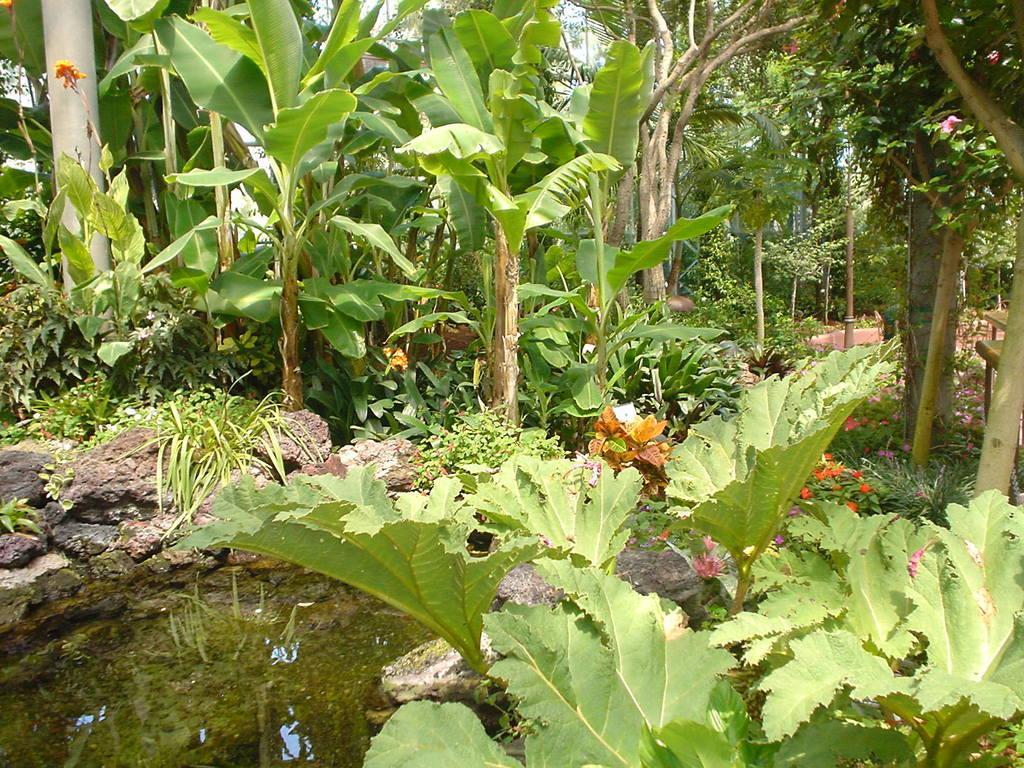Describe this image in one or two sentences. In this image we can see plants, flowers and trees. Left bottom of the image water is present. 